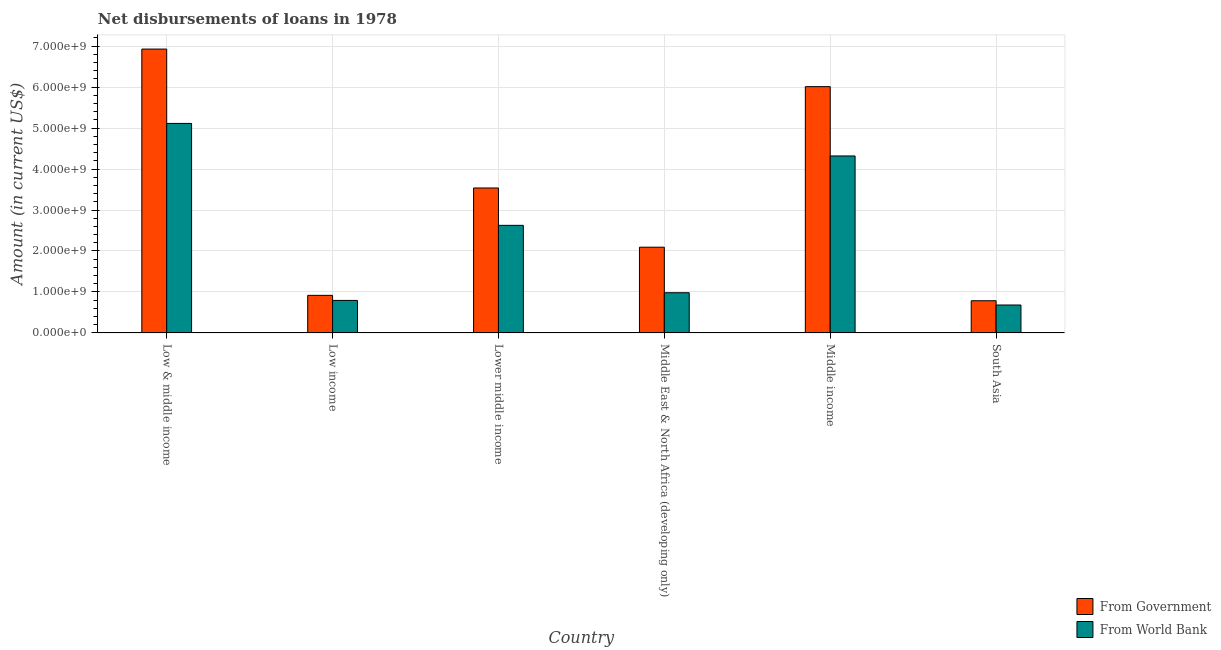Are the number of bars per tick equal to the number of legend labels?
Keep it short and to the point. Yes. Are the number of bars on each tick of the X-axis equal?
Your response must be concise. Yes. How many bars are there on the 3rd tick from the right?
Offer a terse response. 2. What is the label of the 6th group of bars from the left?
Offer a terse response. South Asia. In how many cases, is the number of bars for a given country not equal to the number of legend labels?
Provide a short and direct response. 0. What is the net disbursements of loan from government in Low income?
Keep it short and to the point. 9.17e+08. Across all countries, what is the maximum net disbursements of loan from government?
Your answer should be compact. 6.93e+09. Across all countries, what is the minimum net disbursements of loan from world bank?
Your answer should be compact. 6.82e+08. What is the total net disbursements of loan from world bank in the graph?
Your answer should be compact. 1.45e+1. What is the difference between the net disbursements of loan from government in Low income and that in Middle East & North Africa (developing only)?
Offer a very short reply. -1.18e+09. What is the difference between the net disbursements of loan from world bank in Low income and the net disbursements of loan from government in Middle East & North Africa (developing only)?
Offer a terse response. -1.30e+09. What is the average net disbursements of loan from government per country?
Offer a very short reply. 3.38e+09. What is the difference between the net disbursements of loan from government and net disbursements of loan from world bank in Low & middle income?
Ensure brevity in your answer.  1.82e+09. In how many countries, is the net disbursements of loan from world bank greater than 5200000000 US$?
Make the answer very short. 0. What is the ratio of the net disbursements of loan from government in Middle East & North Africa (developing only) to that in South Asia?
Keep it short and to the point. 2.66. Is the difference between the net disbursements of loan from world bank in Lower middle income and Middle East & North Africa (developing only) greater than the difference between the net disbursements of loan from government in Lower middle income and Middle East & North Africa (developing only)?
Provide a succinct answer. Yes. What is the difference between the highest and the second highest net disbursements of loan from world bank?
Offer a very short reply. 7.94e+08. What is the difference between the highest and the lowest net disbursements of loan from world bank?
Make the answer very short. 4.43e+09. Is the sum of the net disbursements of loan from government in Middle East & North Africa (developing only) and South Asia greater than the maximum net disbursements of loan from world bank across all countries?
Give a very brief answer. No. What does the 1st bar from the left in Low income represents?
Keep it short and to the point. From Government. What does the 1st bar from the right in South Asia represents?
Make the answer very short. From World Bank. Are all the bars in the graph horizontal?
Provide a succinct answer. No. What is the difference between two consecutive major ticks on the Y-axis?
Keep it short and to the point. 1.00e+09. Does the graph contain any zero values?
Provide a succinct answer. No. Where does the legend appear in the graph?
Your answer should be very brief. Bottom right. How many legend labels are there?
Ensure brevity in your answer.  2. What is the title of the graph?
Make the answer very short. Net disbursements of loans in 1978. Does "Formally registered" appear as one of the legend labels in the graph?
Your answer should be compact. No. What is the label or title of the Y-axis?
Provide a succinct answer. Amount (in current US$). What is the Amount (in current US$) of From Government in Low & middle income?
Your answer should be compact. 6.93e+09. What is the Amount (in current US$) of From World Bank in Low & middle income?
Ensure brevity in your answer.  5.11e+09. What is the Amount (in current US$) of From Government in Low income?
Your answer should be very brief. 9.17e+08. What is the Amount (in current US$) of From World Bank in Low income?
Give a very brief answer. 7.94e+08. What is the Amount (in current US$) of From Government in Lower middle income?
Provide a short and direct response. 3.54e+09. What is the Amount (in current US$) in From World Bank in Lower middle income?
Offer a terse response. 2.63e+09. What is the Amount (in current US$) of From Government in Middle East & North Africa (developing only)?
Provide a short and direct response. 2.09e+09. What is the Amount (in current US$) in From World Bank in Middle East & North Africa (developing only)?
Make the answer very short. 9.81e+08. What is the Amount (in current US$) in From Government in Middle income?
Offer a terse response. 6.01e+09. What is the Amount (in current US$) in From World Bank in Middle income?
Ensure brevity in your answer.  4.32e+09. What is the Amount (in current US$) of From Government in South Asia?
Make the answer very short. 7.86e+08. What is the Amount (in current US$) in From World Bank in South Asia?
Give a very brief answer. 6.82e+08. Across all countries, what is the maximum Amount (in current US$) in From Government?
Offer a very short reply. 6.93e+09. Across all countries, what is the maximum Amount (in current US$) of From World Bank?
Offer a very short reply. 5.11e+09. Across all countries, what is the minimum Amount (in current US$) in From Government?
Keep it short and to the point. 7.86e+08. Across all countries, what is the minimum Amount (in current US$) in From World Bank?
Offer a terse response. 6.82e+08. What is the total Amount (in current US$) in From Government in the graph?
Your answer should be compact. 2.03e+1. What is the total Amount (in current US$) of From World Bank in the graph?
Your answer should be compact. 1.45e+1. What is the difference between the Amount (in current US$) in From Government in Low & middle income and that in Low income?
Your answer should be compact. 6.01e+09. What is the difference between the Amount (in current US$) of From World Bank in Low & middle income and that in Low income?
Ensure brevity in your answer.  4.32e+09. What is the difference between the Amount (in current US$) of From Government in Low & middle income and that in Lower middle income?
Provide a short and direct response. 3.39e+09. What is the difference between the Amount (in current US$) of From World Bank in Low & middle income and that in Lower middle income?
Offer a terse response. 2.49e+09. What is the difference between the Amount (in current US$) in From Government in Low & middle income and that in Middle East & North Africa (developing only)?
Offer a very short reply. 4.84e+09. What is the difference between the Amount (in current US$) of From World Bank in Low & middle income and that in Middle East & North Africa (developing only)?
Your answer should be compact. 4.13e+09. What is the difference between the Amount (in current US$) in From Government in Low & middle income and that in Middle income?
Offer a terse response. 9.17e+08. What is the difference between the Amount (in current US$) in From World Bank in Low & middle income and that in Middle income?
Offer a very short reply. 7.94e+08. What is the difference between the Amount (in current US$) in From Government in Low & middle income and that in South Asia?
Offer a terse response. 6.14e+09. What is the difference between the Amount (in current US$) in From World Bank in Low & middle income and that in South Asia?
Provide a short and direct response. 4.43e+09. What is the difference between the Amount (in current US$) of From Government in Low income and that in Lower middle income?
Ensure brevity in your answer.  -2.62e+09. What is the difference between the Amount (in current US$) in From World Bank in Low income and that in Lower middle income?
Provide a short and direct response. -1.83e+09. What is the difference between the Amount (in current US$) of From Government in Low income and that in Middle East & North Africa (developing only)?
Offer a very short reply. -1.18e+09. What is the difference between the Amount (in current US$) in From World Bank in Low income and that in Middle East & North Africa (developing only)?
Provide a succinct answer. -1.88e+08. What is the difference between the Amount (in current US$) in From Government in Low income and that in Middle income?
Provide a short and direct response. -5.09e+09. What is the difference between the Amount (in current US$) of From World Bank in Low income and that in Middle income?
Offer a very short reply. -3.53e+09. What is the difference between the Amount (in current US$) in From Government in Low income and that in South Asia?
Provide a short and direct response. 1.31e+08. What is the difference between the Amount (in current US$) of From World Bank in Low income and that in South Asia?
Offer a very short reply. 1.12e+08. What is the difference between the Amount (in current US$) in From Government in Lower middle income and that in Middle East & North Africa (developing only)?
Give a very brief answer. 1.45e+09. What is the difference between the Amount (in current US$) in From World Bank in Lower middle income and that in Middle East & North Africa (developing only)?
Offer a terse response. 1.64e+09. What is the difference between the Amount (in current US$) of From Government in Lower middle income and that in Middle income?
Make the answer very short. -2.47e+09. What is the difference between the Amount (in current US$) in From World Bank in Lower middle income and that in Middle income?
Offer a terse response. -1.69e+09. What is the difference between the Amount (in current US$) of From Government in Lower middle income and that in South Asia?
Ensure brevity in your answer.  2.75e+09. What is the difference between the Amount (in current US$) of From World Bank in Lower middle income and that in South Asia?
Give a very brief answer. 1.94e+09. What is the difference between the Amount (in current US$) of From Government in Middle East & North Africa (developing only) and that in Middle income?
Offer a terse response. -3.92e+09. What is the difference between the Amount (in current US$) of From World Bank in Middle East & North Africa (developing only) and that in Middle income?
Your response must be concise. -3.34e+09. What is the difference between the Amount (in current US$) in From Government in Middle East & North Africa (developing only) and that in South Asia?
Keep it short and to the point. 1.31e+09. What is the difference between the Amount (in current US$) in From World Bank in Middle East & North Africa (developing only) and that in South Asia?
Your response must be concise. 2.99e+08. What is the difference between the Amount (in current US$) of From Government in Middle income and that in South Asia?
Provide a short and direct response. 5.23e+09. What is the difference between the Amount (in current US$) of From World Bank in Middle income and that in South Asia?
Offer a terse response. 3.64e+09. What is the difference between the Amount (in current US$) of From Government in Low & middle income and the Amount (in current US$) of From World Bank in Low income?
Keep it short and to the point. 6.13e+09. What is the difference between the Amount (in current US$) of From Government in Low & middle income and the Amount (in current US$) of From World Bank in Lower middle income?
Provide a succinct answer. 4.30e+09. What is the difference between the Amount (in current US$) of From Government in Low & middle income and the Amount (in current US$) of From World Bank in Middle East & North Africa (developing only)?
Provide a succinct answer. 5.95e+09. What is the difference between the Amount (in current US$) in From Government in Low & middle income and the Amount (in current US$) in From World Bank in Middle income?
Your response must be concise. 2.61e+09. What is the difference between the Amount (in current US$) of From Government in Low & middle income and the Amount (in current US$) of From World Bank in South Asia?
Offer a terse response. 6.25e+09. What is the difference between the Amount (in current US$) in From Government in Low income and the Amount (in current US$) in From World Bank in Lower middle income?
Your response must be concise. -1.71e+09. What is the difference between the Amount (in current US$) in From Government in Low income and the Amount (in current US$) in From World Bank in Middle East & North Africa (developing only)?
Make the answer very short. -6.39e+07. What is the difference between the Amount (in current US$) of From Government in Low income and the Amount (in current US$) of From World Bank in Middle income?
Make the answer very short. -3.40e+09. What is the difference between the Amount (in current US$) in From Government in Low income and the Amount (in current US$) in From World Bank in South Asia?
Give a very brief answer. 2.36e+08. What is the difference between the Amount (in current US$) in From Government in Lower middle income and the Amount (in current US$) in From World Bank in Middle East & North Africa (developing only)?
Your response must be concise. 2.56e+09. What is the difference between the Amount (in current US$) in From Government in Lower middle income and the Amount (in current US$) in From World Bank in Middle income?
Offer a very short reply. -7.82e+08. What is the difference between the Amount (in current US$) of From Government in Lower middle income and the Amount (in current US$) of From World Bank in South Asia?
Offer a very short reply. 2.86e+09. What is the difference between the Amount (in current US$) in From Government in Middle East & North Africa (developing only) and the Amount (in current US$) in From World Bank in Middle income?
Offer a very short reply. -2.23e+09. What is the difference between the Amount (in current US$) in From Government in Middle East & North Africa (developing only) and the Amount (in current US$) in From World Bank in South Asia?
Your answer should be compact. 1.41e+09. What is the difference between the Amount (in current US$) of From Government in Middle income and the Amount (in current US$) of From World Bank in South Asia?
Make the answer very short. 5.33e+09. What is the average Amount (in current US$) in From Government per country?
Offer a very short reply. 3.38e+09. What is the average Amount (in current US$) of From World Bank per country?
Give a very brief answer. 2.42e+09. What is the difference between the Amount (in current US$) in From Government and Amount (in current US$) in From World Bank in Low & middle income?
Provide a short and direct response. 1.82e+09. What is the difference between the Amount (in current US$) in From Government and Amount (in current US$) in From World Bank in Low income?
Your answer should be compact. 1.24e+08. What is the difference between the Amount (in current US$) of From Government and Amount (in current US$) of From World Bank in Lower middle income?
Offer a terse response. 9.12e+08. What is the difference between the Amount (in current US$) of From Government and Amount (in current US$) of From World Bank in Middle East & North Africa (developing only)?
Your answer should be compact. 1.11e+09. What is the difference between the Amount (in current US$) of From Government and Amount (in current US$) of From World Bank in Middle income?
Your answer should be compact. 1.69e+09. What is the difference between the Amount (in current US$) in From Government and Amount (in current US$) in From World Bank in South Asia?
Provide a short and direct response. 1.04e+08. What is the ratio of the Amount (in current US$) of From Government in Low & middle income to that in Low income?
Offer a very short reply. 7.55. What is the ratio of the Amount (in current US$) of From World Bank in Low & middle income to that in Low income?
Keep it short and to the point. 6.44. What is the ratio of the Amount (in current US$) of From Government in Low & middle income to that in Lower middle income?
Offer a terse response. 1.96. What is the ratio of the Amount (in current US$) in From World Bank in Low & middle income to that in Lower middle income?
Offer a very short reply. 1.95. What is the ratio of the Amount (in current US$) in From Government in Low & middle income to that in Middle East & North Africa (developing only)?
Provide a short and direct response. 3.31. What is the ratio of the Amount (in current US$) in From World Bank in Low & middle income to that in Middle East & North Africa (developing only)?
Make the answer very short. 5.21. What is the ratio of the Amount (in current US$) in From Government in Low & middle income to that in Middle income?
Make the answer very short. 1.15. What is the ratio of the Amount (in current US$) of From World Bank in Low & middle income to that in Middle income?
Provide a short and direct response. 1.18. What is the ratio of the Amount (in current US$) of From Government in Low & middle income to that in South Asia?
Offer a terse response. 8.81. What is the ratio of the Amount (in current US$) in From World Bank in Low & middle income to that in South Asia?
Provide a succinct answer. 7.5. What is the ratio of the Amount (in current US$) in From Government in Low income to that in Lower middle income?
Make the answer very short. 0.26. What is the ratio of the Amount (in current US$) of From World Bank in Low income to that in Lower middle income?
Give a very brief answer. 0.3. What is the ratio of the Amount (in current US$) in From Government in Low income to that in Middle East & North Africa (developing only)?
Keep it short and to the point. 0.44. What is the ratio of the Amount (in current US$) in From World Bank in Low income to that in Middle East & North Africa (developing only)?
Make the answer very short. 0.81. What is the ratio of the Amount (in current US$) of From Government in Low income to that in Middle income?
Your response must be concise. 0.15. What is the ratio of the Amount (in current US$) in From World Bank in Low income to that in Middle income?
Your response must be concise. 0.18. What is the ratio of the Amount (in current US$) in From Government in Low income to that in South Asia?
Provide a short and direct response. 1.17. What is the ratio of the Amount (in current US$) of From World Bank in Low income to that in South Asia?
Offer a terse response. 1.16. What is the ratio of the Amount (in current US$) of From Government in Lower middle income to that in Middle East & North Africa (developing only)?
Ensure brevity in your answer.  1.69. What is the ratio of the Amount (in current US$) of From World Bank in Lower middle income to that in Middle East & North Africa (developing only)?
Give a very brief answer. 2.68. What is the ratio of the Amount (in current US$) in From Government in Lower middle income to that in Middle income?
Make the answer very short. 0.59. What is the ratio of the Amount (in current US$) of From World Bank in Lower middle income to that in Middle income?
Your answer should be very brief. 0.61. What is the ratio of the Amount (in current US$) of From Government in Lower middle income to that in South Asia?
Provide a short and direct response. 4.5. What is the ratio of the Amount (in current US$) in From World Bank in Lower middle income to that in South Asia?
Offer a terse response. 3.85. What is the ratio of the Amount (in current US$) of From Government in Middle East & North Africa (developing only) to that in Middle income?
Ensure brevity in your answer.  0.35. What is the ratio of the Amount (in current US$) of From World Bank in Middle East & North Africa (developing only) to that in Middle income?
Ensure brevity in your answer.  0.23. What is the ratio of the Amount (in current US$) of From Government in Middle East & North Africa (developing only) to that in South Asia?
Your answer should be compact. 2.66. What is the ratio of the Amount (in current US$) of From World Bank in Middle East & North Africa (developing only) to that in South Asia?
Your answer should be compact. 1.44. What is the ratio of the Amount (in current US$) in From Government in Middle income to that in South Asia?
Offer a very short reply. 7.65. What is the ratio of the Amount (in current US$) in From World Bank in Middle income to that in South Asia?
Your response must be concise. 6.34. What is the difference between the highest and the second highest Amount (in current US$) in From Government?
Make the answer very short. 9.17e+08. What is the difference between the highest and the second highest Amount (in current US$) of From World Bank?
Make the answer very short. 7.94e+08. What is the difference between the highest and the lowest Amount (in current US$) in From Government?
Provide a succinct answer. 6.14e+09. What is the difference between the highest and the lowest Amount (in current US$) in From World Bank?
Keep it short and to the point. 4.43e+09. 